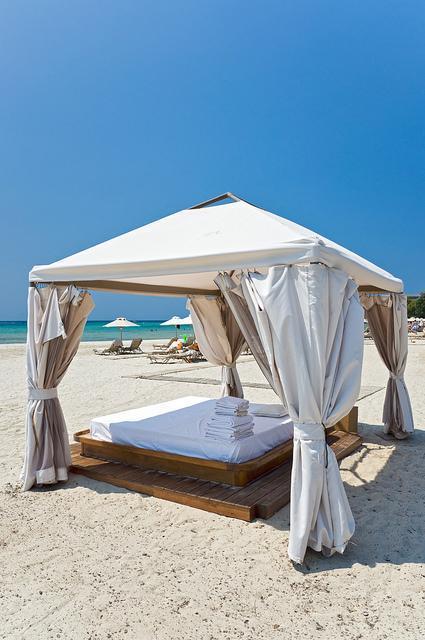What will this tent offer protection from?
Choose the correct response, then elucidate: 'Answer: answer
Rationale: rationale.'
Options: Tsunami, insects, gangs, sun. Answer: sun.
Rationale: This is on the beach on a clear day so it will block the sun 